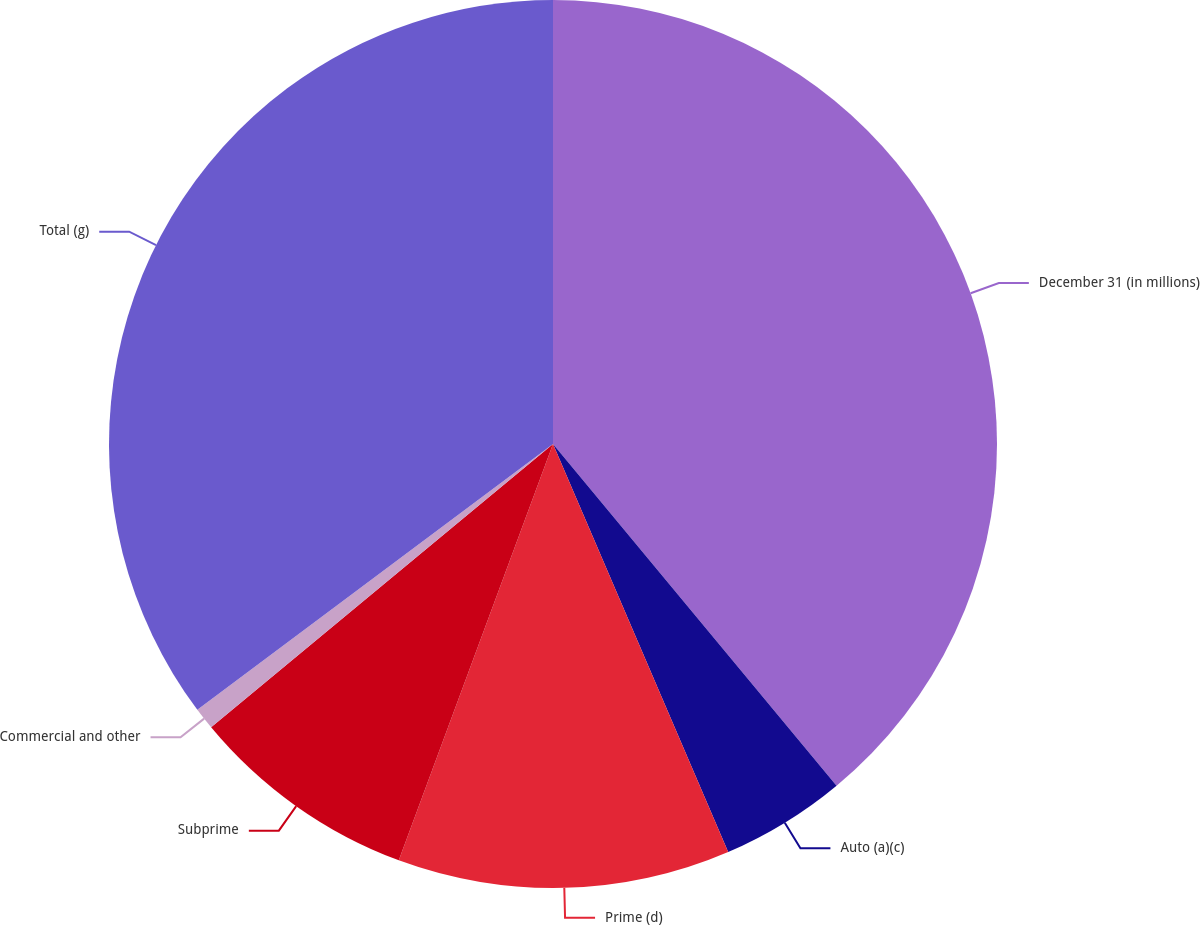Convert chart to OTSL. <chart><loc_0><loc_0><loc_500><loc_500><pie_chart><fcel>December 31 (in millions)<fcel>Auto (a)(c)<fcel>Prime (d)<fcel>Subprime<fcel>Commercial and other<fcel>Total (g)<nl><fcel>38.97%<fcel>4.57%<fcel>12.1%<fcel>8.34%<fcel>0.8%<fcel>35.21%<nl></chart> 